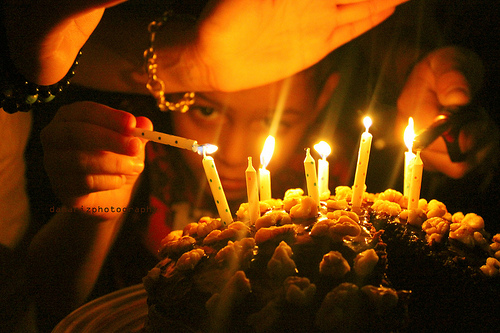<image>
Can you confirm if the candle is next to the cake? No. The candle is not positioned next to the cake. They are located in different areas of the scene. 